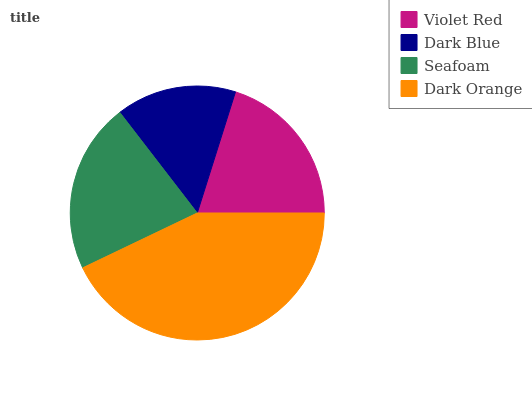Is Dark Blue the minimum?
Answer yes or no. Yes. Is Dark Orange the maximum?
Answer yes or no. Yes. Is Seafoam the minimum?
Answer yes or no. No. Is Seafoam the maximum?
Answer yes or no. No. Is Seafoam greater than Dark Blue?
Answer yes or no. Yes. Is Dark Blue less than Seafoam?
Answer yes or no. Yes. Is Dark Blue greater than Seafoam?
Answer yes or no. No. Is Seafoam less than Dark Blue?
Answer yes or no. No. Is Seafoam the high median?
Answer yes or no. Yes. Is Violet Red the low median?
Answer yes or no. Yes. Is Dark Orange the high median?
Answer yes or no. No. Is Dark Orange the low median?
Answer yes or no. No. 